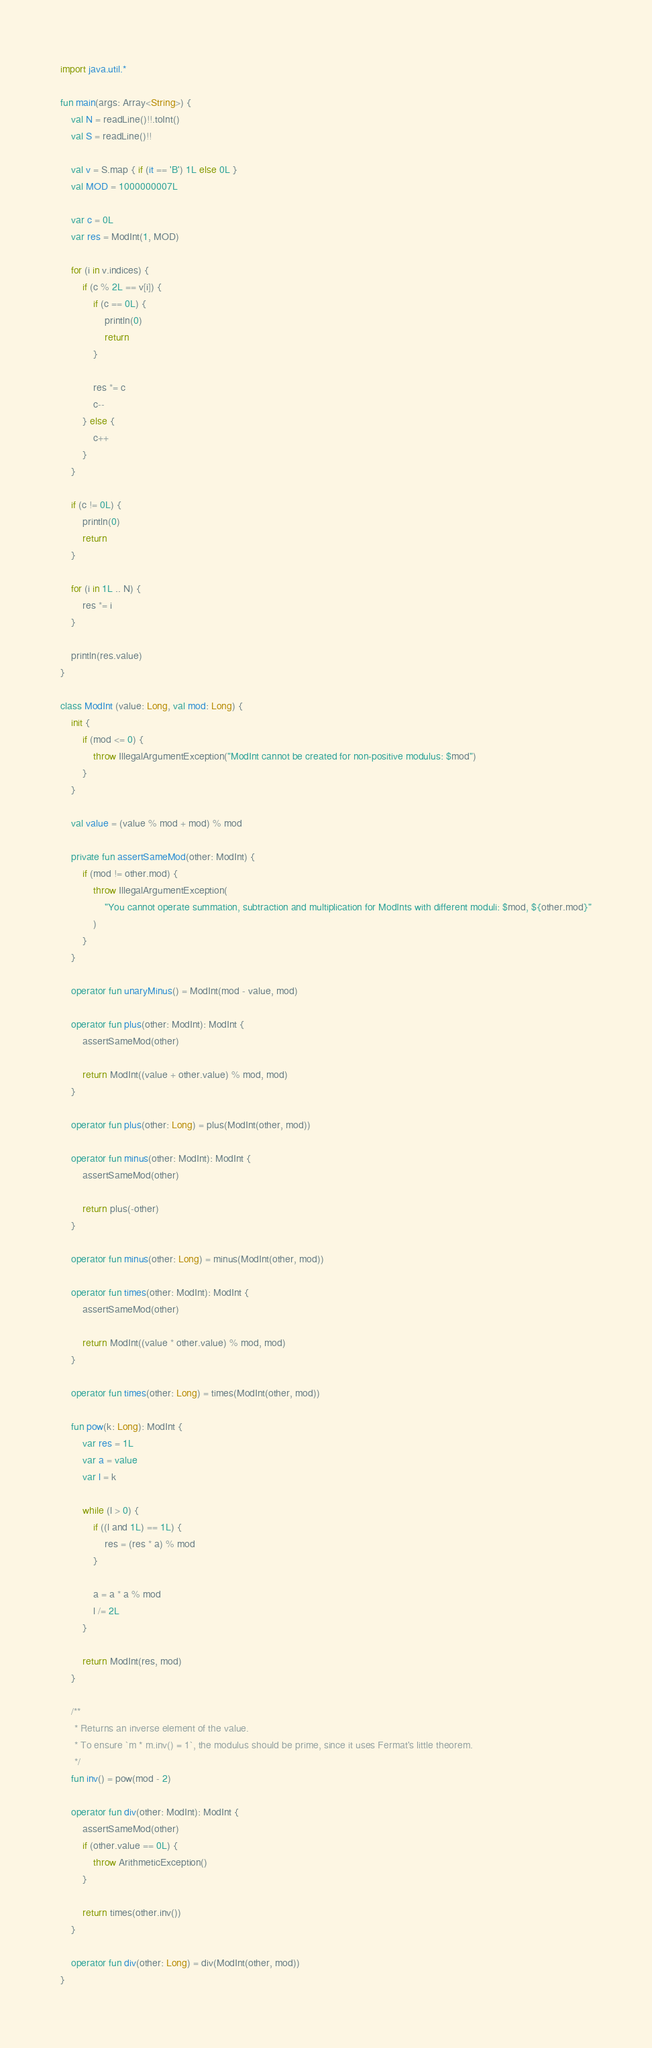Convert code to text. <code><loc_0><loc_0><loc_500><loc_500><_Kotlin_>import java.util.*

fun main(args: Array<String>) {
    val N = readLine()!!.toInt()
    val S = readLine()!!

    val v = S.map { if (it == 'B') 1L else 0L }
    val MOD = 1000000007L

    var c = 0L
    var res = ModInt(1, MOD)

    for (i in v.indices) {
        if (c % 2L == v[i]) {
            if (c == 0L) {
                println(0)
                return
            }

            res *= c
            c--
        } else {
            c++
        }
    }

    if (c != 0L) {
        println(0)
        return
    }

    for (i in 1L .. N) {
        res *= i
    }

    println(res.value)
}

class ModInt (value: Long, val mod: Long) {
    init {
        if (mod <= 0) {
            throw IllegalArgumentException("ModInt cannot be created for non-positive modulus: $mod")
        }
    }

    val value = (value % mod + mod) % mod

    private fun assertSameMod(other: ModInt) {
        if (mod != other.mod) {
            throw IllegalArgumentException(
                "You cannot operate summation, subtraction and multiplication for ModInts with different moduli: $mod, ${other.mod}"
            )
        }
    }

    operator fun unaryMinus() = ModInt(mod - value, mod)

    operator fun plus(other: ModInt): ModInt {
        assertSameMod(other)

        return ModInt((value + other.value) % mod, mod)
    }

    operator fun plus(other: Long) = plus(ModInt(other, mod))

    operator fun minus(other: ModInt): ModInt {
        assertSameMod(other)

        return plus(-other)
    }

    operator fun minus(other: Long) = minus(ModInt(other, mod))

    operator fun times(other: ModInt): ModInt {
        assertSameMod(other)

        return ModInt((value * other.value) % mod, mod)
    }

    operator fun times(other: Long) = times(ModInt(other, mod))

    fun pow(k: Long): ModInt {
        var res = 1L
        var a = value
        var l = k

        while (l > 0) {
            if ((l and 1L) == 1L) {
                res = (res * a) % mod
            }

            a = a * a % mod
            l /= 2L
        }

        return ModInt(res, mod)
    }

    /**
     * Returns an inverse element of the value.
     * To ensure `m * m.inv() = 1`, the modulus should be prime, since it uses Fermat's little theorem.
     */
    fun inv() = pow(mod - 2)

    operator fun div(other: ModInt): ModInt {
        assertSameMod(other)
        if (other.value == 0L) {
            throw ArithmeticException()
        }

        return times(other.inv())
    }

    operator fun div(other: Long) = div(ModInt(other, mod))
}
</code> 